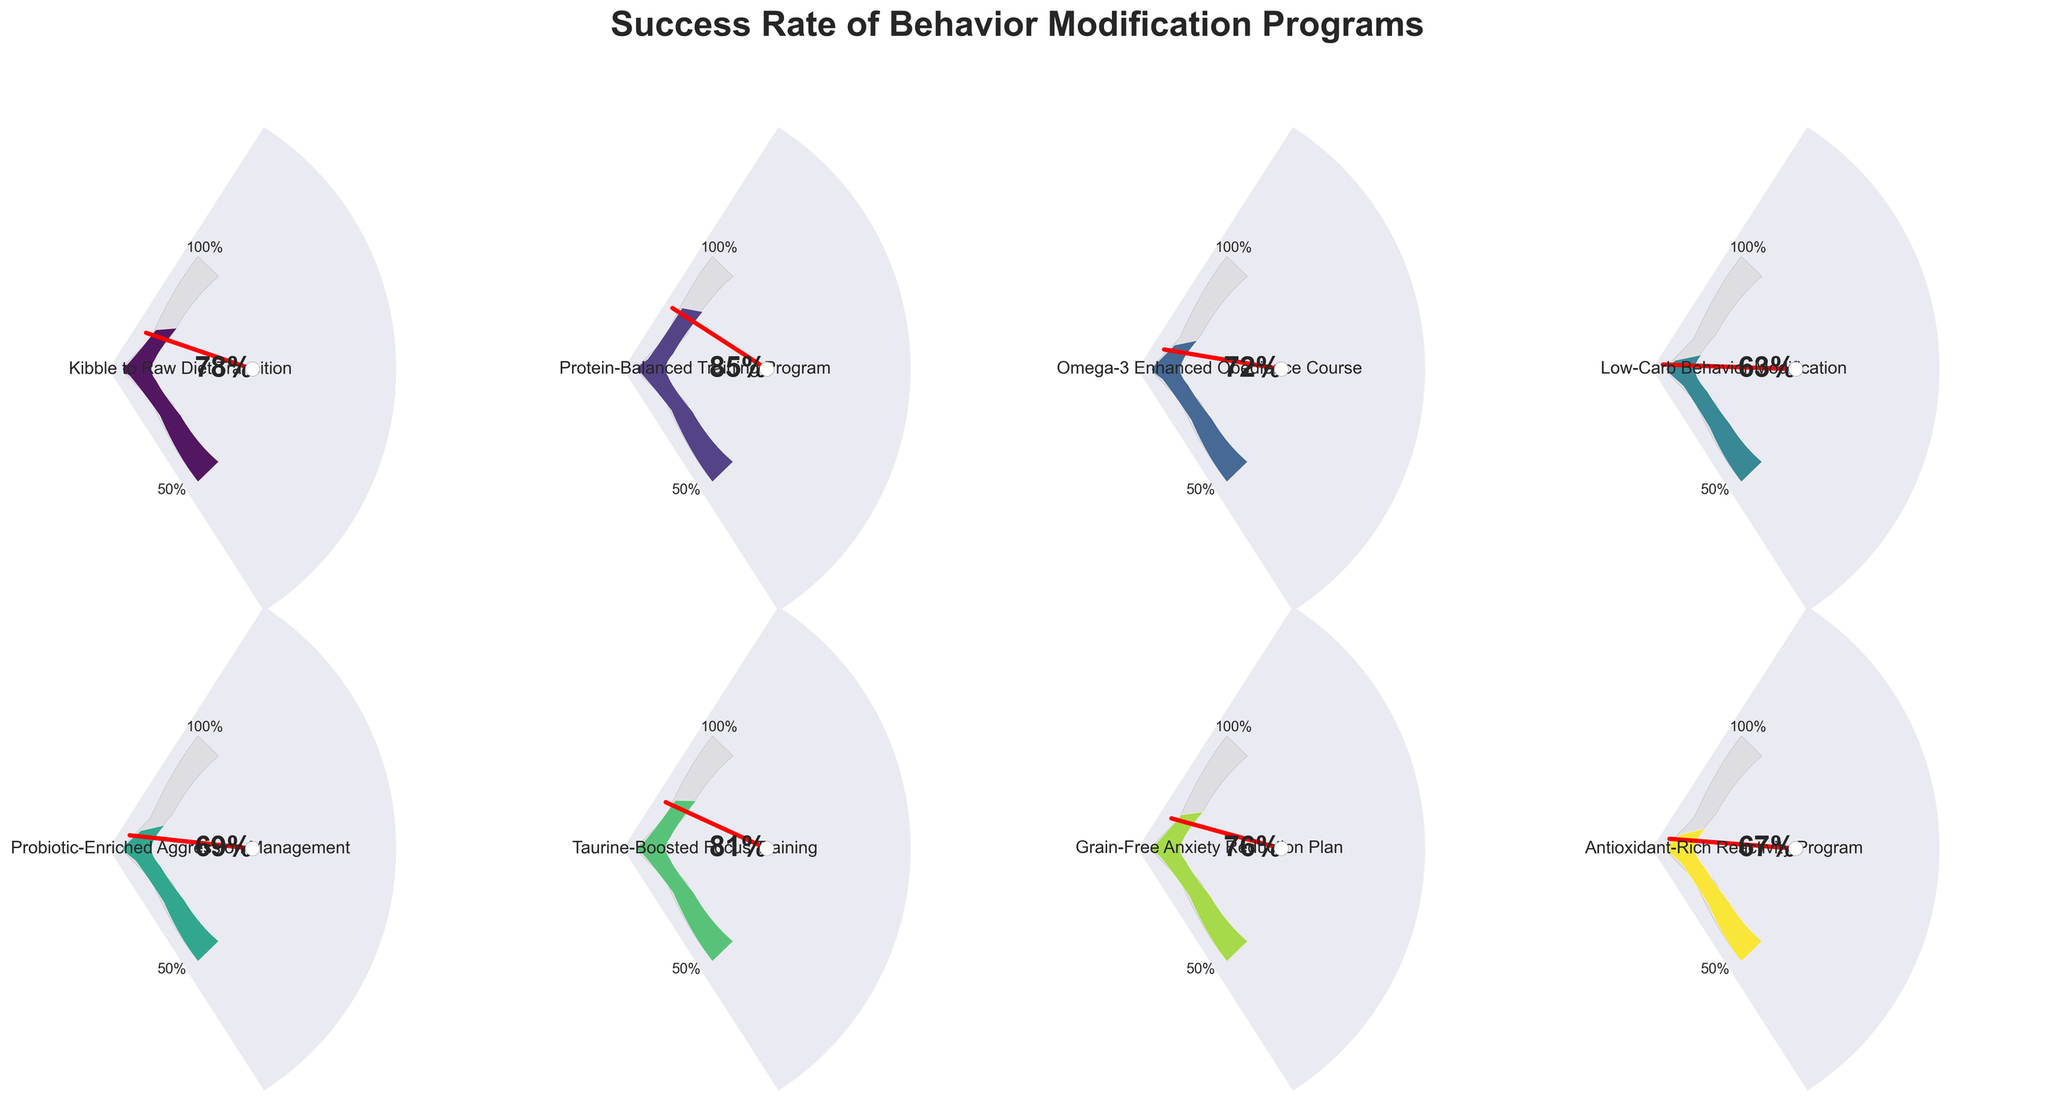What is the title of the figure? The figure's title is usually located at the top and summarizes what the chart is about. In this case, the title given is 'Success Rate of Behavior Modification Programs', as mentioned at the top of each subplot.
Answer: Success Rate of Behavior Modification Programs How many behavior modification programs are shown in the figure? Count the number of distinct gauge charts. Each gauge chart represents one program, and there are 8 gauge charts in the figure.
Answer: 8 Which program has the highest success rate? Identify the gauge chart with the highest percentage indicated. The 'Protein-Balanced Training Program' has a success rate of 85%.
Answer: Protein-Balanced Training Program What is the success rate of the Grain-Free Anxiety Reduction Plan? Find the gauge chart labeled 'Grain-Free Anxiety Reduction Plan' and read the percentage displayed, which is 76%.
Answer: 76% Which program shows the lowest success rate? Compare all success rates and find the smallest percentage. The 'Low-Carb Behavior Modification' program has the lowest rate at 63%.
Answer: Low-Carb Behavior Modification How does the success rate of the Omega-3 Enhanced Obedience Course compare to the Probiotic-Enriched Aggression Management? Compare the success rates of both programs. 'Omega-3 Enhanced Obedience Course' has 72%, and 'Probiotic-Enriched Aggression Management' has 69%. 72% is higher than 69%.
Answer: Higher What is the average success rate of all the programs combined? Add all success rates together (78 + 85 + 72 + 63 + 69 + 81 + 76 + 67) and divide by the number of programs (8). The total is 591, and the average is 591/8 = 73.875.
Answer: 73.875 Which programs have success rates above 80%? Identify programs with success rates exceeding 80%. Both 'Protein-Balanced Training Program' (85%) and 'Taurine-Boosted Focus Training' (81%) meet this criterion.
Answer: Protein-Balanced Training Program, Taurine-Boosted Focus Training Which two programs have the closest success rates? Look for two programs whose success rates are numerically the closest. 'Probiotic-Enriched Aggression Management' (69%) and 'Antioxidant-Rich Reactivity Program' (67%) have the smallest difference, being 2%.
Answer: Probiotic-Enriched Aggression Management, Antioxidant-Rich Reactivity Program What is the difference in success rate between the Grain-Free Anxiety Reduction Plan and the Low-Carb Behavior Modification? Subtract the success rate of 'Low-Carb Behavior Modification' (63%) from that of 'Grain-Free Anxiety Reduction Plan' (76%). The difference is 76% - 63% = 13%.
Answer: 13% 